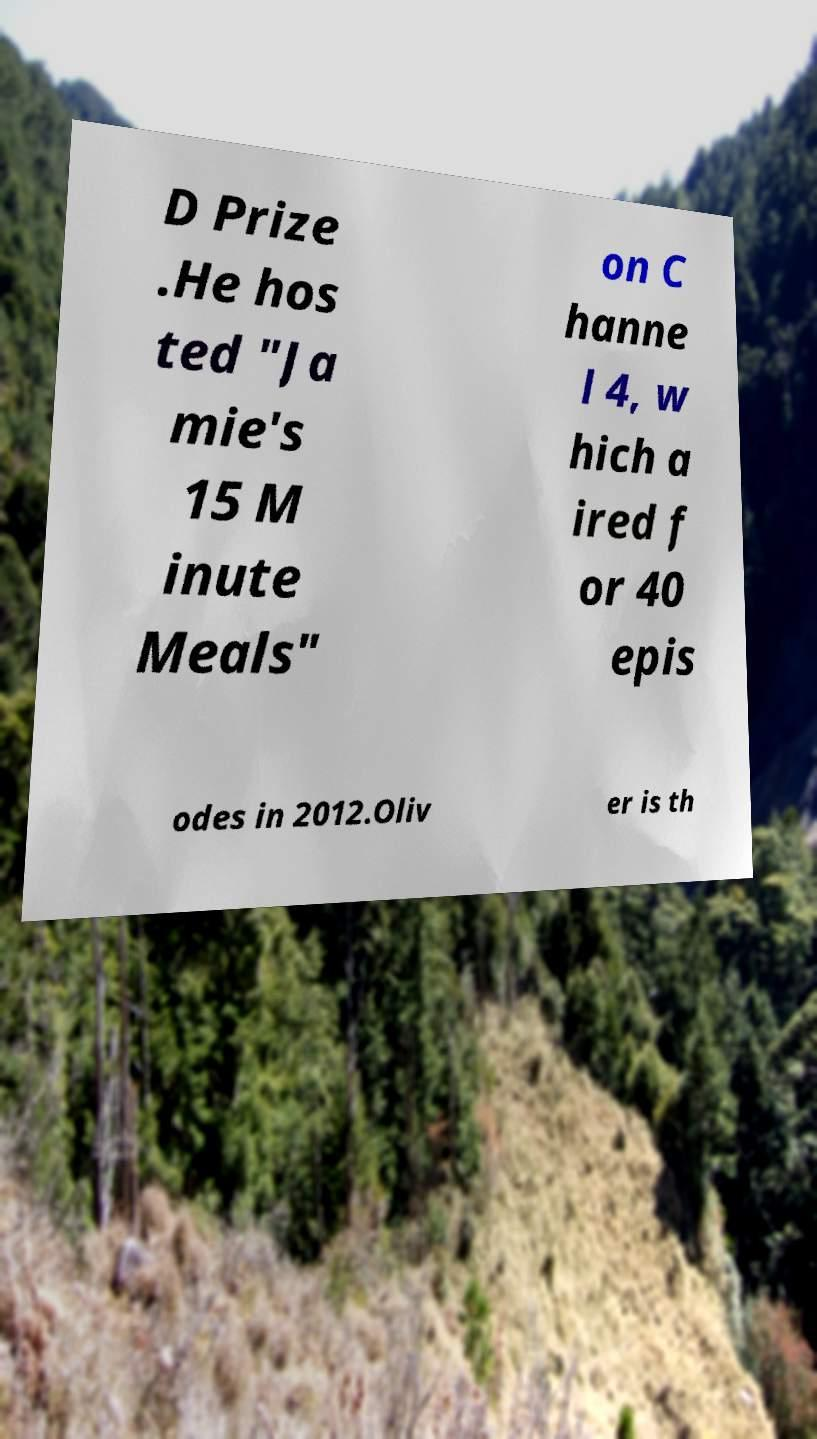Can you read and provide the text displayed in the image?This photo seems to have some interesting text. Can you extract and type it out for me? D Prize .He hos ted "Ja mie's 15 M inute Meals" on C hanne l 4, w hich a ired f or 40 epis odes in 2012.Oliv er is th 